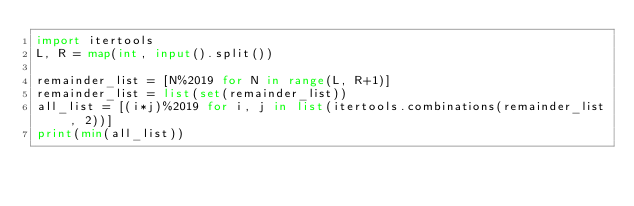<code> <loc_0><loc_0><loc_500><loc_500><_Python_>import itertools
L, R = map(int, input().split())
 
remainder_list = [N%2019 for N in range(L, R+1)]
remainder_list = list(set(remainder_list))
all_list = [(i*j)%2019 for i, j in list(itertools.combinations(remainder_list, 2))]
print(min(all_list))</code> 